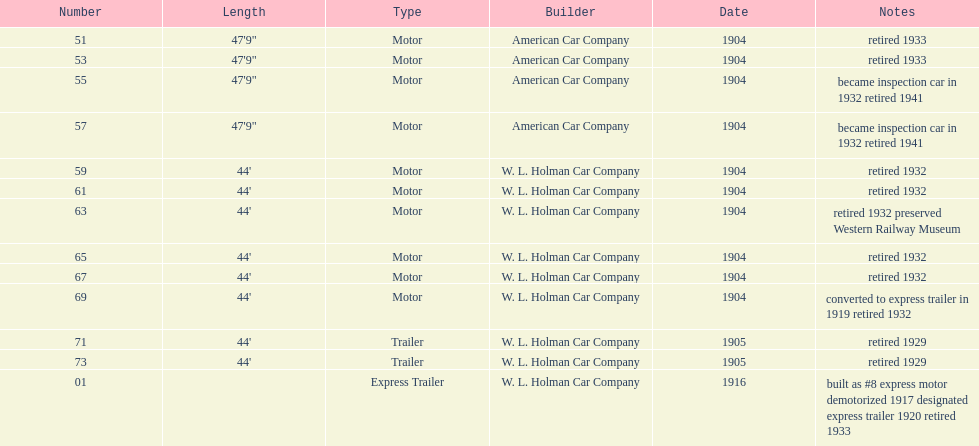What was the number of cars built by american car company? 4. 